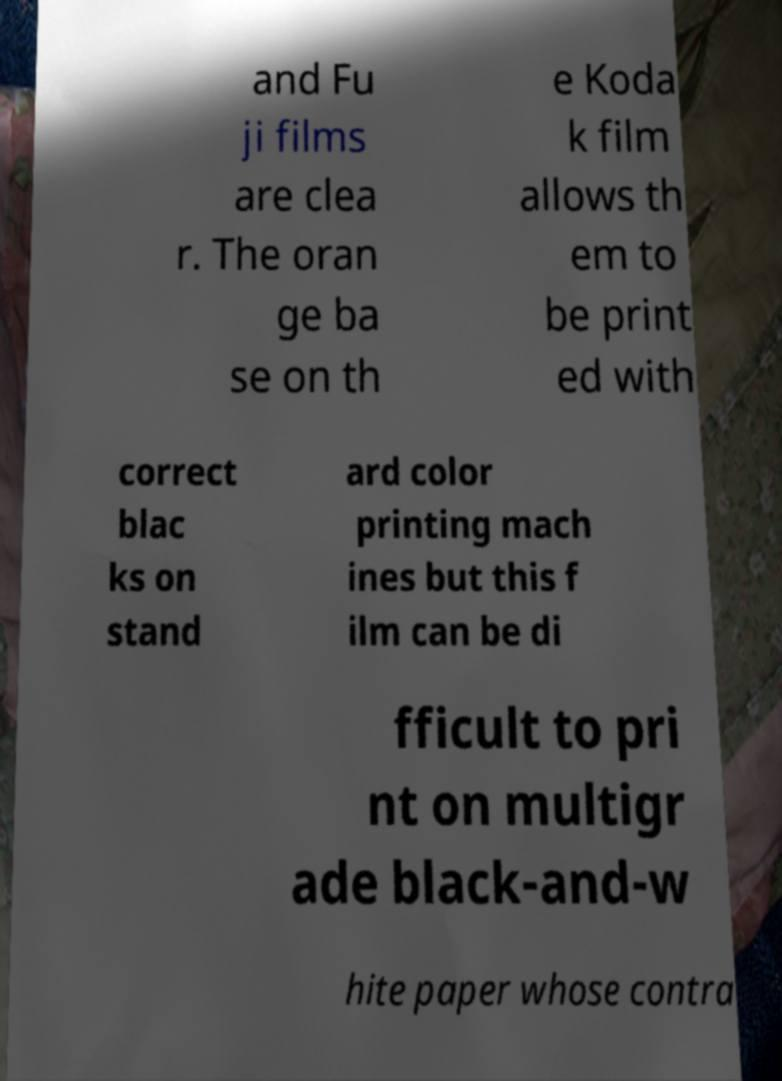Could you extract and type out the text from this image? and Fu ji films are clea r. The oran ge ba se on th e Koda k film allows th em to be print ed with correct blac ks on stand ard color printing mach ines but this f ilm can be di fficult to pri nt on multigr ade black-and-w hite paper whose contra 